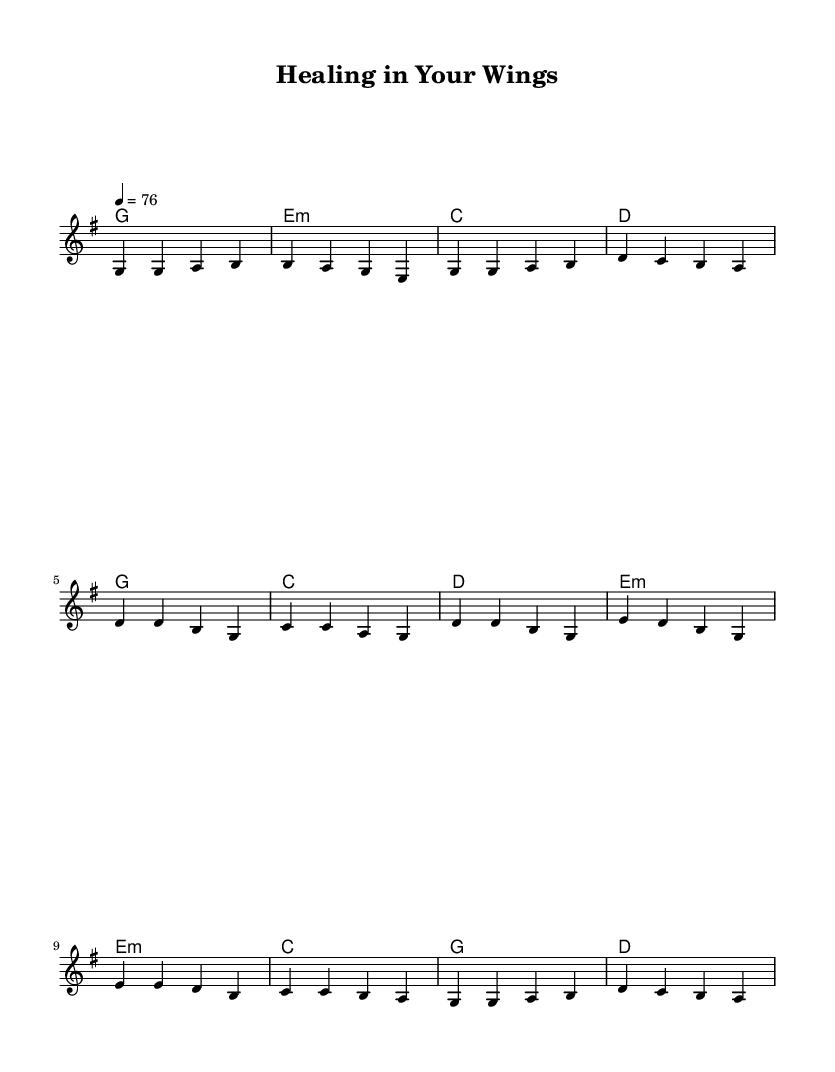What is the key signature of this music? The key signature is G major, which has one sharp (F#).
Answer: G major What is the time signature of this piece? The time signature is 4/4, indicating four beats per measure.
Answer: 4/4 What is the tempo marking indicated in the music? The tempo marking is quarter note equals seventy-six beats per minute.
Answer: seventy-six How many measures are in the chorus section? The chorus consists of four measures, each containing a different chord progression.
Answer: four What is the first lyric line of the verse? The first line of the verse states, "In the depths of pain and sorrow."
Answer: In the depths of pain and sorrow Which section includes the lyric "You're the Great Physician"? The lyric "You're the Great Physician" appears in the bridge section of the song.
Answer: bridge How does the melody in the bridge compare to the verse? The melody in the bridge shows a rise in pitch that can evoke a sense of upliftment compared to the verse.
Answer: rise in pitch 